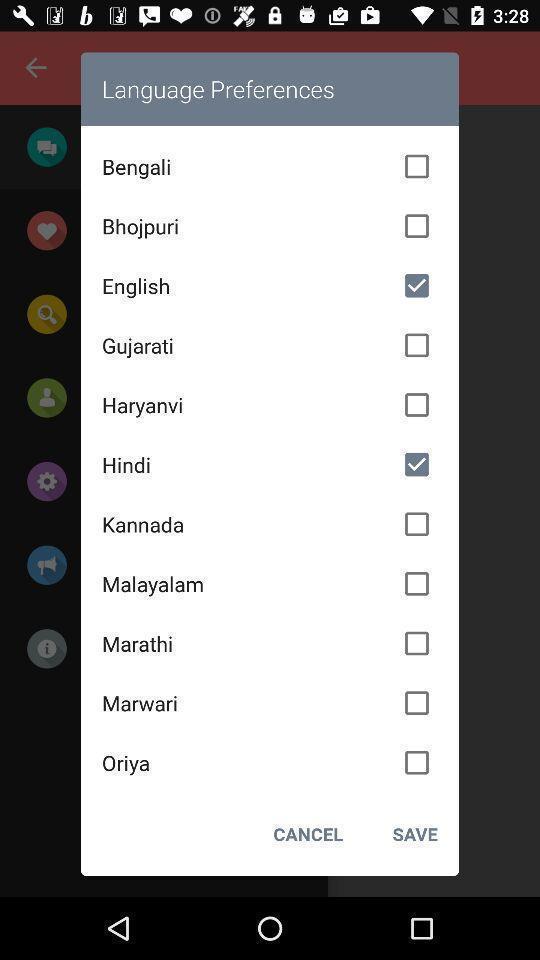Tell me about the visual elements in this screen capture. Pop-up displaying list of various languages. 